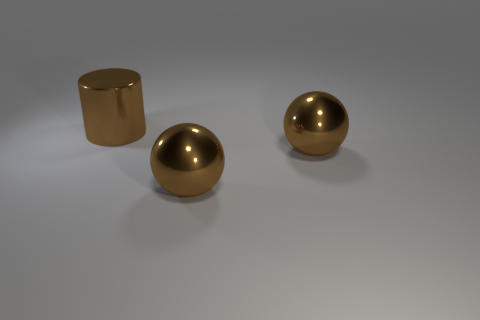How many objects are either brown shiny things that are right of the large brown cylinder or objects that are on the right side of the big brown shiny cylinder?
Your answer should be compact. 2. How many objects are green metallic things or brown balls?
Your answer should be very brief. 2. How many brown balls have the same size as the brown cylinder?
Provide a short and direct response. 2. Are there any things that have the same color as the shiny cylinder?
Provide a succinct answer. Yes. What is the color of the cylinder?
Make the answer very short. Brown. Is the number of large metallic cylinders behind the large brown cylinder less than the number of objects?
Your response must be concise. Yes. Is there a small yellow metallic block?
Your answer should be very brief. No. What number of blocks are large metal objects or tiny objects?
Offer a terse response. 0. Is there anything else that is made of the same material as the large cylinder?
Your response must be concise. Yes. What number of other objects are the same size as the cylinder?
Provide a succinct answer. 2. 